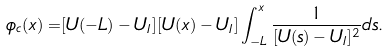Convert formula to latex. <formula><loc_0><loc_0><loc_500><loc_500>\phi _ { c } ( x ) = & [ U ( - L ) - U _ { I } ] [ U ( x ) - U _ { I } ] \int _ { - L } ^ { x } \frac { 1 } { [ U ( s ) - U _ { I } ] ^ { 2 } } d s .</formula> 